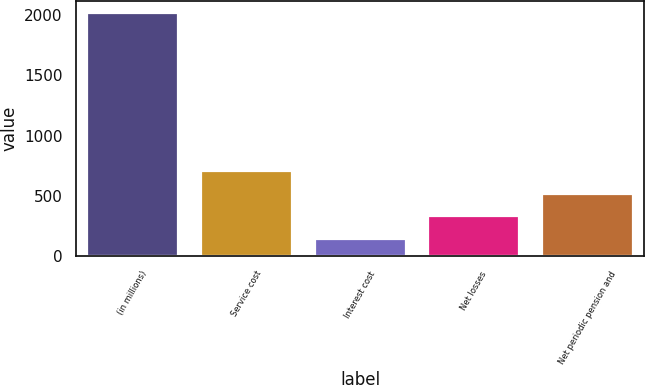Convert chart to OTSL. <chart><loc_0><loc_0><loc_500><loc_500><bar_chart><fcel>(in millions)<fcel>Service cost<fcel>Interest cost<fcel>Net losses<fcel>Net periodic pension and<nl><fcel>2016<fcel>707<fcel>146<fcel>333<fcel>520<nl></chart> 